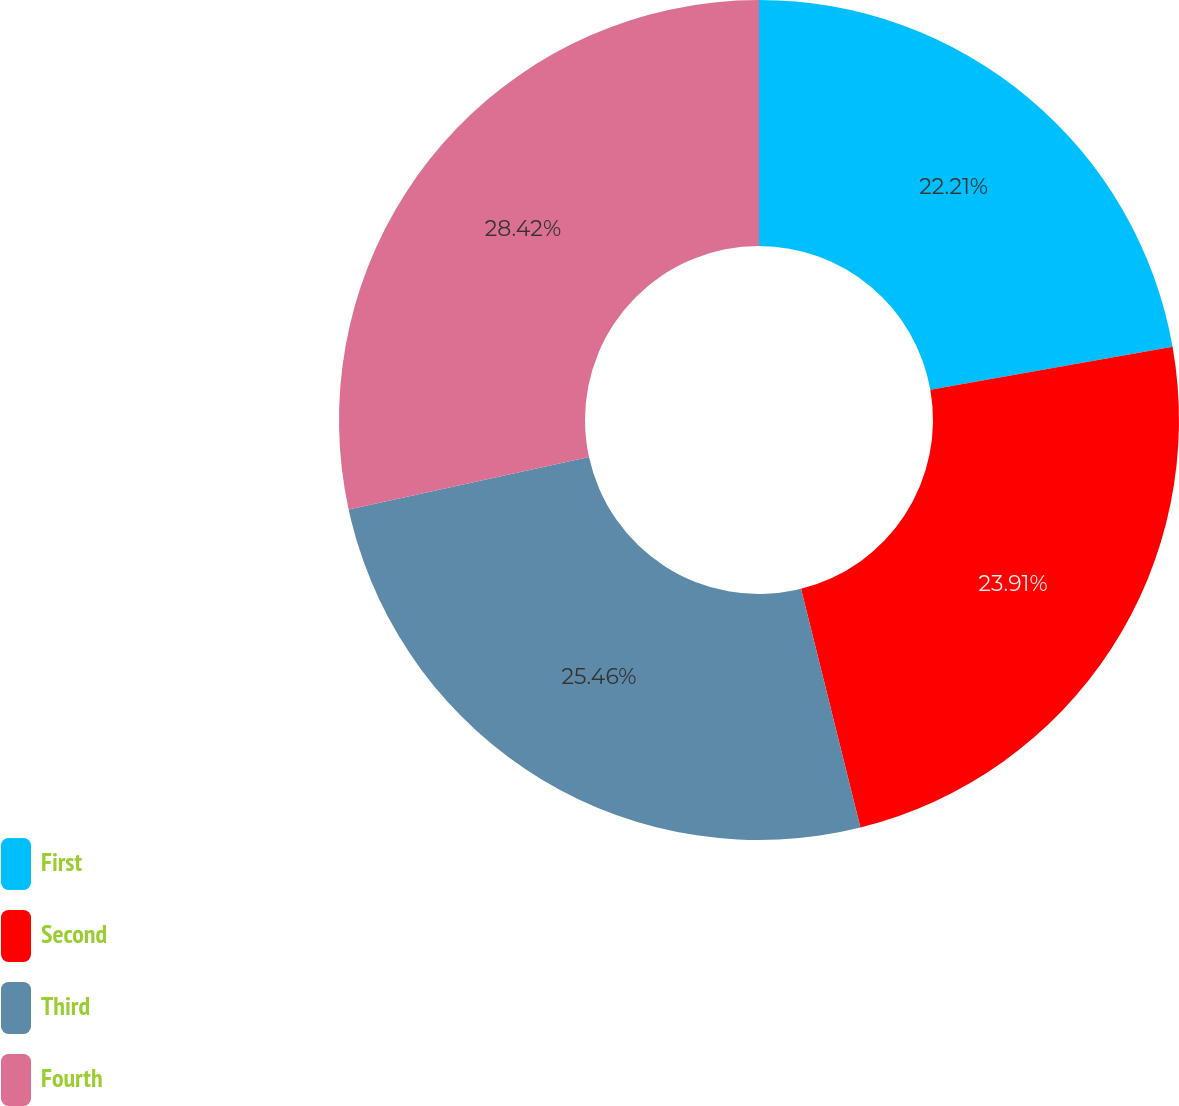Convert chart to OTSL. <chart><loc_0><loc_0><loc_500><loc_500><pie_chart><fcel>First<fcel>Second<fcel>Third<fcel>Fourth<nl><fcel>22.21%<fcel>23.91%<fcel>25.46%<fcel>28.42%<nl></chart> 